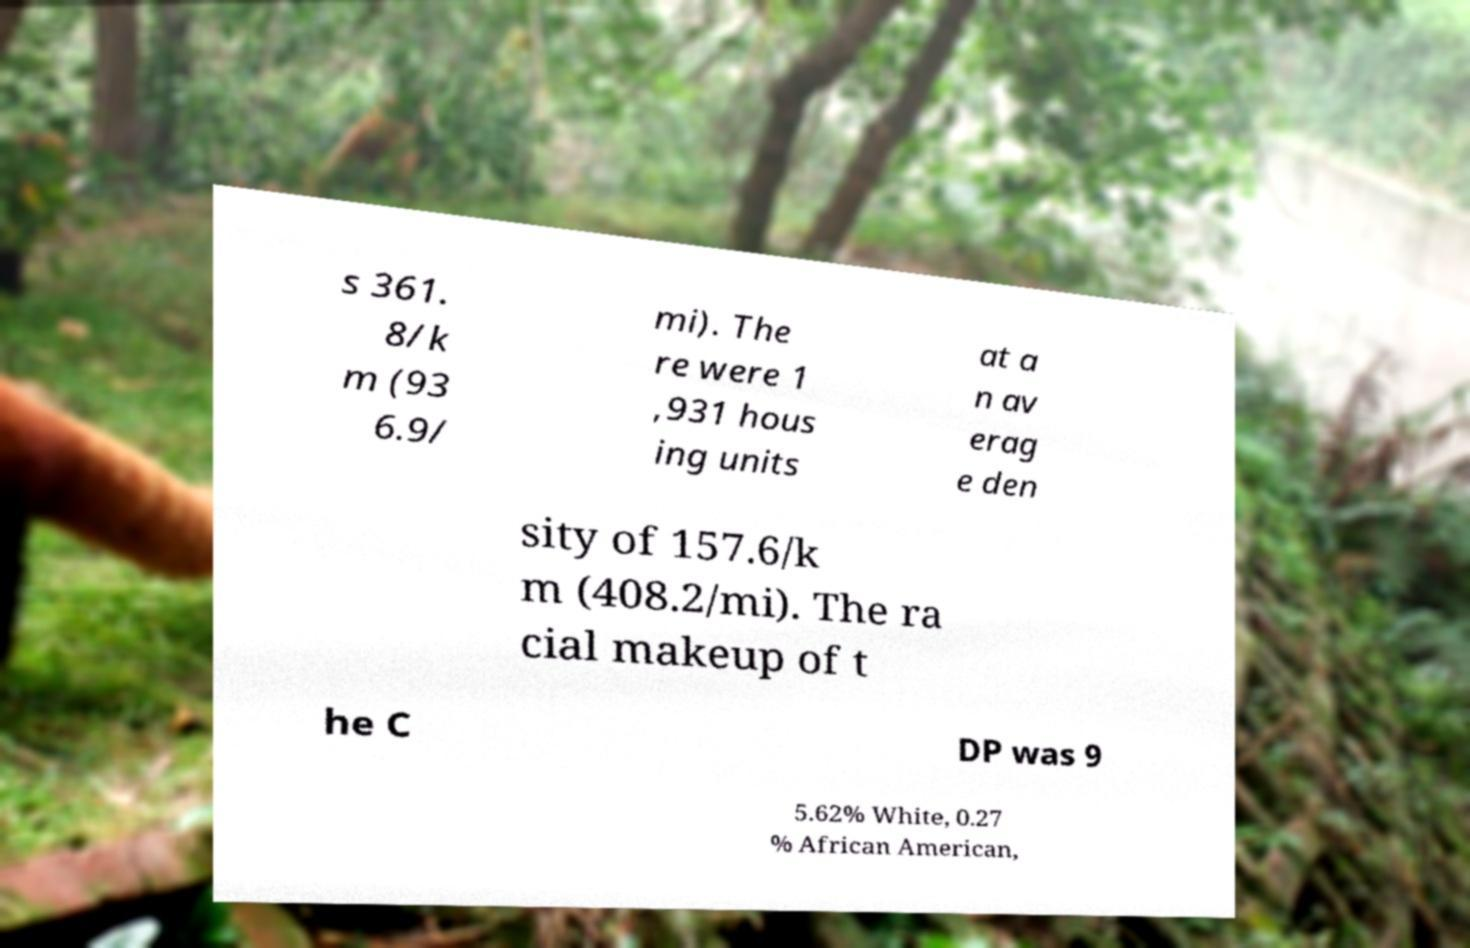I need the written content from this picture converted into text. Can you do that? s 361. 8/k m (93 6.9/ mi). The re were 1 ,931 hous ing units at a n av erag e den sity of 157.6/k m (408.2/mi). The ra cial makeup of t he C DP was 9 5.62% White, 0.27 % African American, 